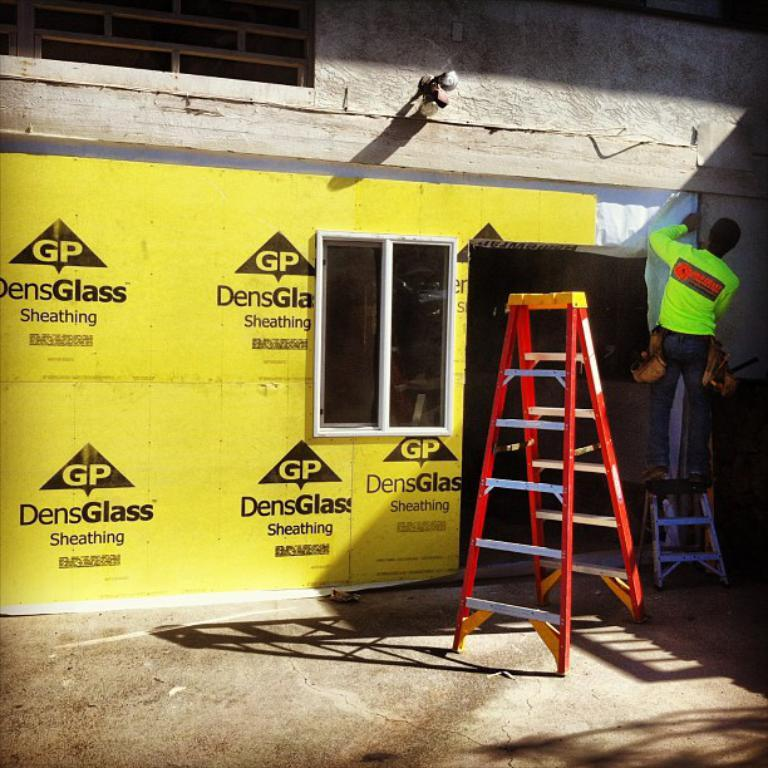What is the person in the image doing? The person is standing on a ladder on the right side of the image. Can you describe the other ladder in the image? There is another ladder near the person. What can be seen in the background of the image? There is a wall in the background of the image, and a poster is pasted on the wall. What architectural feature is visible in the image? There is a window in the image. What type of planes can be seen flying in the image? There are no planes visible in the image. What is the person using to rake leaves in the image? There is no rake present in the image, and the person is not performing any activity related to raking leaves. 